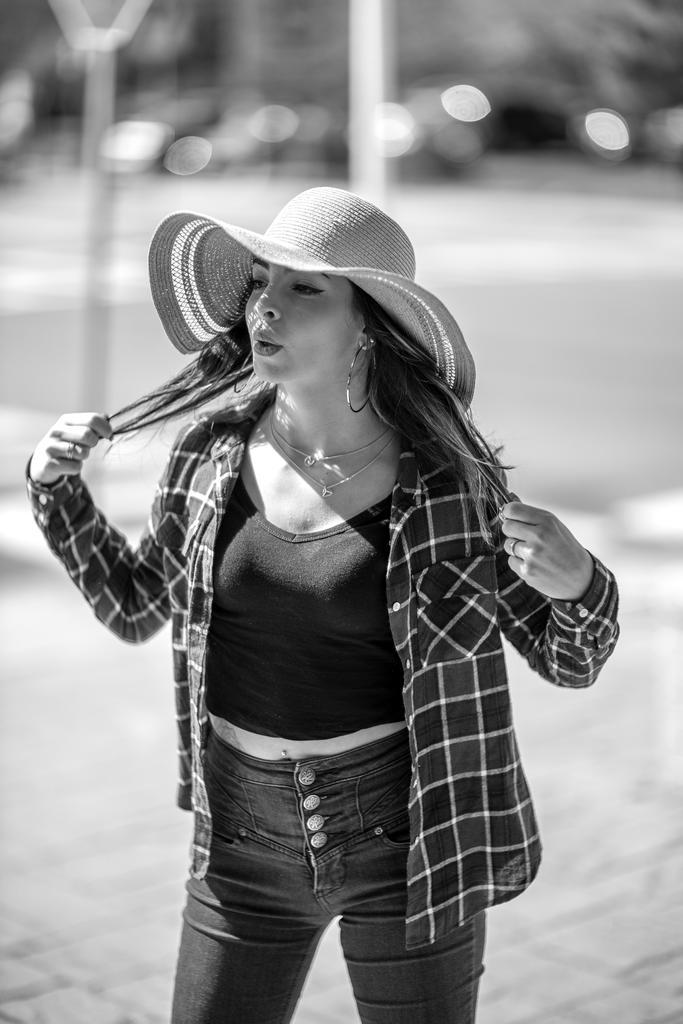Who is present in the image? There is a woman in the picture. What is the woman wearing on her head? The woman is wearing a hat. What is the color scheme of the image? The image is in black and white color. What type of flower is the woman holding in the image? There is no flower present in the image; the woman is not holding anything. 